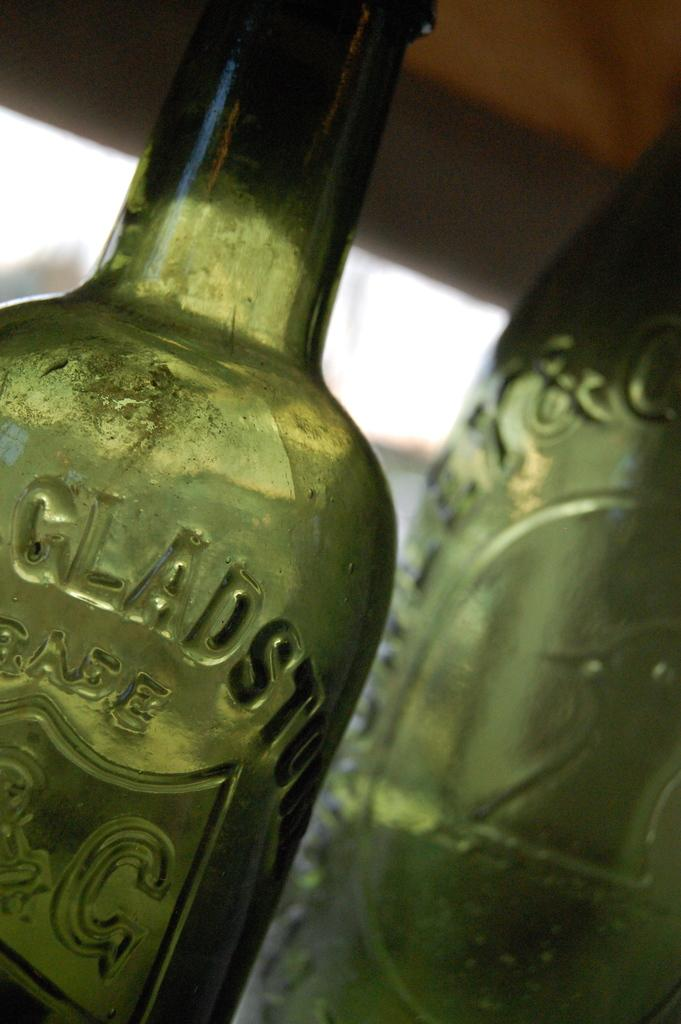What objects are present in the image? There are two green color bottles in the image. Can you describe the background of the image? The background of the image is blurred. What type of wool is being used to wrap the box in the image? There is no box or wool present in the image; it only features two green color bottles. 